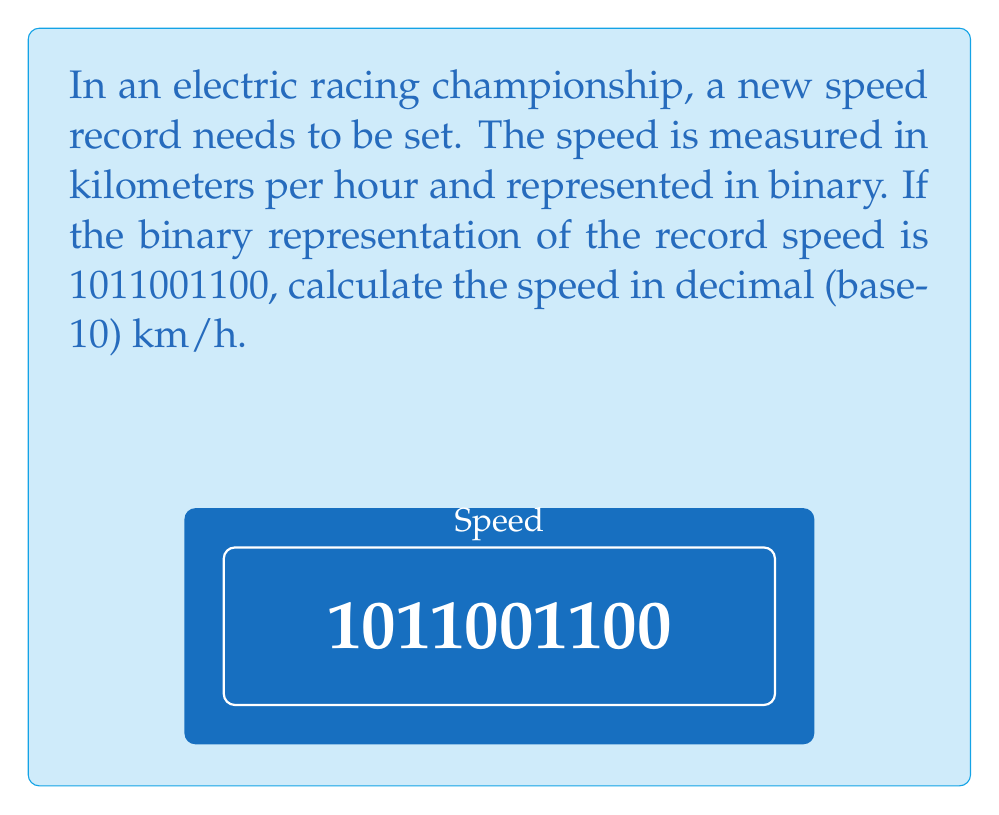Teach me how to tackle this problem. To solve this problem, we need to convert the binary number to decimal. Let's break it down step-by-step:

1) The binary number is 1011001100.

2) In binary, each digit represents a power of 2, starting from the rightmost digit and increasing as we move left. The value of each position is calculated as follows:

   $$1 \cdot 2^9 + 0 \cdot 2^8 + 1 \cdot 2^7 + 1 \cdot 2^6 + 0 \cdot 2^5 + 0 \cdot 2^4 + 1 \cdot 2^3 + 1 \cdot 2^2 + 0 \cdot 2^1 + 0 \cdot 2^0$$

3) Let's calculate each term:

   $$1 \cdot 512 + 0 \cdot 256 + 1 \cdot 128 + 1 \cdot 64 + 0 \cdot 32 + 0 \cdot 16 + 1 \cdot 8 + 1 \cdot 4 + 0 \cdot 2 + 0 \cdot 1$$

4) Simplifying:

   $$512 + 0 + 128 + 64 + 0 + 0 + 8 + 4 + 0 + 0$$

5) Adding these numbers:

   $$512 + 128 + 64 + 8 + 4 = 716$$

Therefore, the speed represented by the binary number 1011001100 is 716 km/h in decimal.
Answer: 716 km/h 